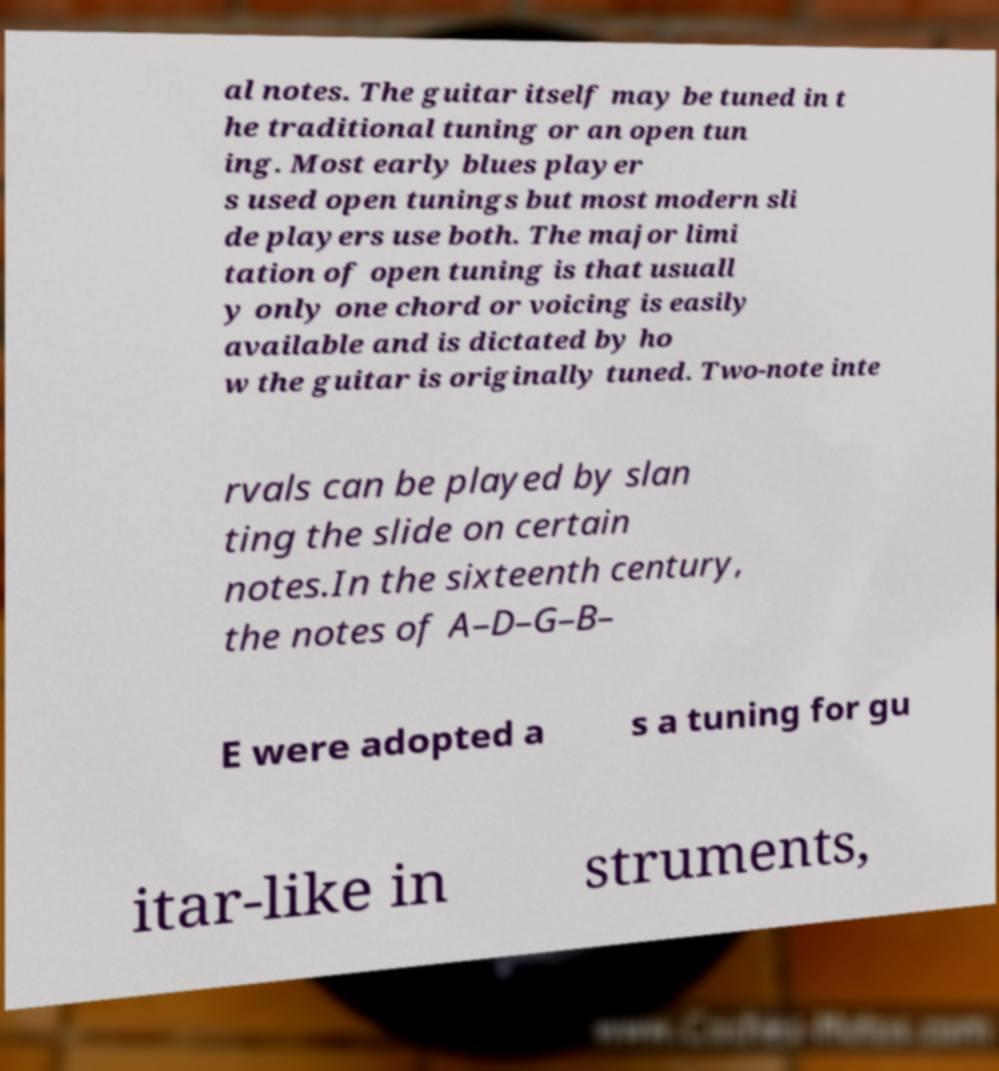Please read and relay the text visible in this image. What does it say? al notes. The guitar itself may be tuned in t he traditional tuning or an open tun ing. Most early blues player s used open tunings but most modern sli de players use both. The major limi tation of open tuning is that usuall y only one chord or voicing is easily available and is dictated by ho w the guitar is originally tuned. Two-note inte rvals can be played by slan ting the slide on certain notes.In the sixteenth century, the notes of A–D–G–B– E were adopted a s a tuning for gu itar-like in struments, 